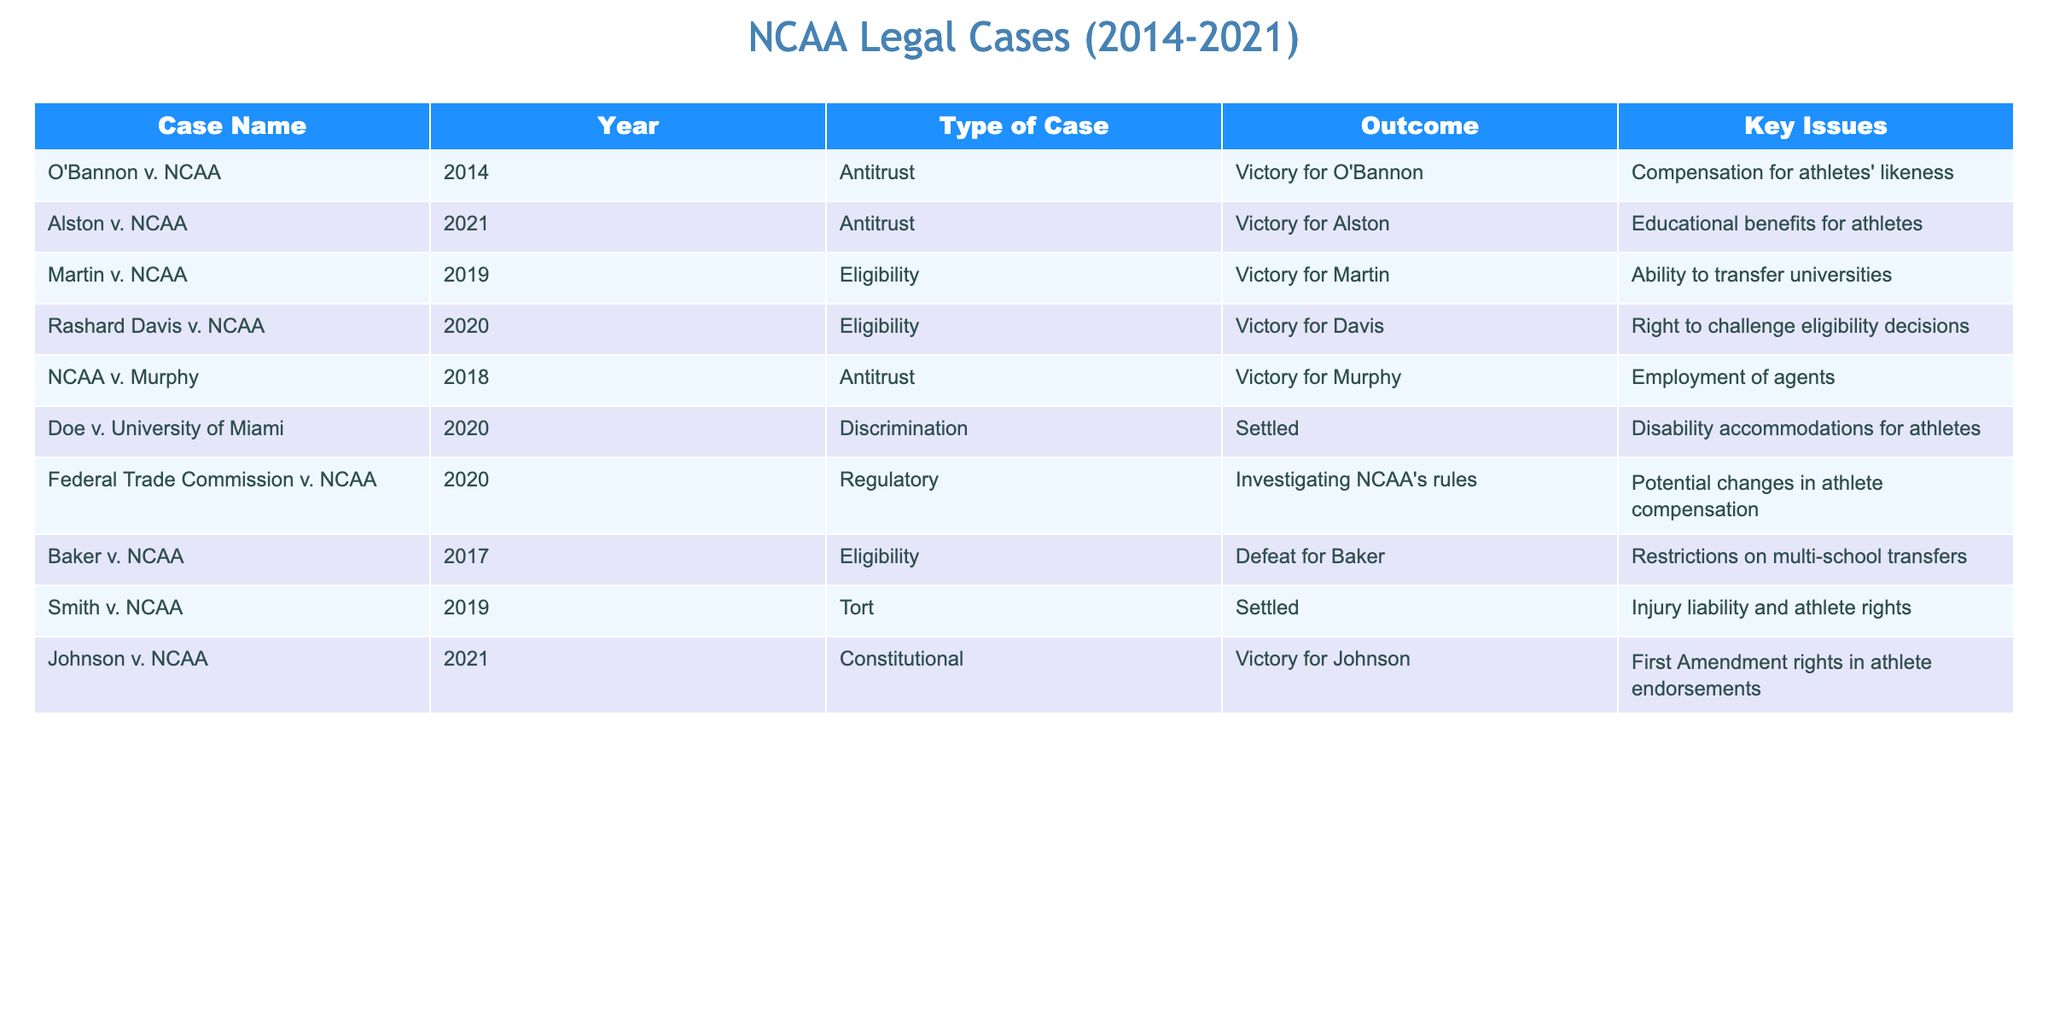What was the outcome of O'Bannon v. NCAA? The outcome for O'Bannon v. NCAA was a victory for O'Bannon. This can be found by looking at the "Outcome" column for the row associated with the case name "O'Bannon v. NCAA."
Answer: Victory for O'Bannon Which legal case addressed the right to challenge eligibility decisions? The case that addressed the right to challenge eligibility decisions is Rashard Davis v. NCAA. I can identify this by checking the "Key Issues" column for the relevant row.
Answer: Rashard Davis v. NCAA How many cases resulted in a victory for the NCAA? To find the number of victories for the NCAA, I need to count the rows with "Defeat for" in the "Outcome" column. There is one case that fits this category, which is Baker v. NCAA. Therefore, there was one victory for the NCAA.
Answer: 1 What type of case was Johnson v. NCAA? The type of case for Johnson v. NCAA can be found under the "Type of Case" column for that specific row. It is categorized as a constitutional case.
Answer: Constitutional Which year had the most legal cases related to NCAA eligibility? To determine the year with the most cases related to NCAA eligibility, I will count the occurrences in the "Year" column where the "Type of Case" is categorized as "Eligibility." There are three cases: Martin v. NCAA, Rashard Davis v. NCAA, and Baker v. NCAA, all occurring in different years. Since there’s no repeat year, we can infer that 2019 and 2021 each had two cases on eligibility.
Answer: 2019 and 2021 Is it true that all cases involving antitrust ended in victories? I can check the "Outcome" column for all cases listed under the "Type of Case" as "Antitrust." The cases are O'Bannon v. NCAA, Alston v. NCAA, and NCAA v. Murphy, all of which resulted in victories. Therefore, it is true that all antitrust cases ended in victories.
Answer: Yes What are the key issues in the case Smith v. NCAA? To find the key issues in Smith v. NCAA, I will look at the "Key Issues" column for that specific case. The issue pertains to injury liability and athlete rights.
Answer: Injury liability and athlete rights Which specific case from 2020 involved disability accommodations for athletes? I can identify the case from 2020 involving disability accommodations for athletes by checking the "Year" column and looking for the specific case. The case is Doe v. University of Miami.
Answer: Doe v. University of Miami How many total cases are presented in the table? To find the total number of cases presented in the table, I will count all the rows of data in the table. There are a total of eight cases listed.
Answer: 8 